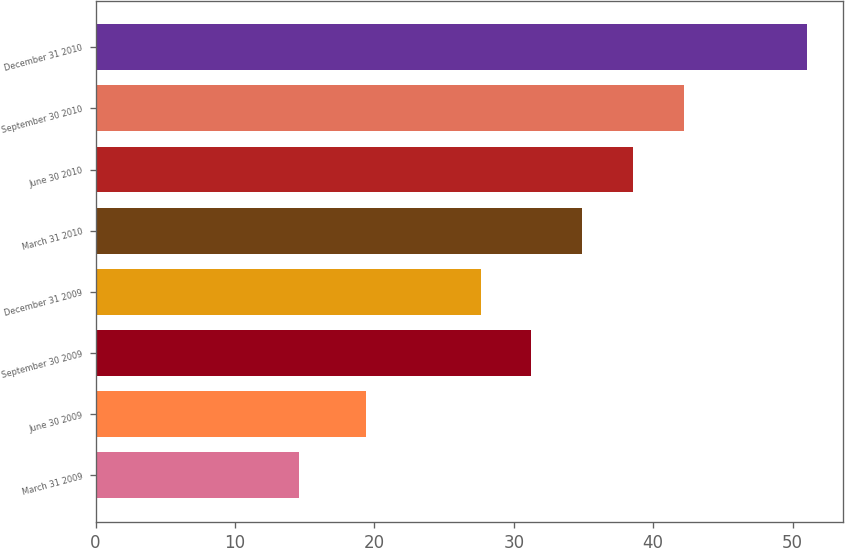Convert chart to OTSL. <chart><loc_0><loc_0><loc_500><loc_500><bar_chart><fcel>March 31 2009<fcel>June 30 2009<fcel>September 30 2009<fcel>December 31 2009<fcel>March 31 2010<fcel>June 30 2010<fcel>September 30 2010<fcel>December 31 2010<nl><fcel>14.62<fcel>19.4<fcel>31.26<fcel>27.62<fcel>34.9<fcel>38.54<fcel>42.18<fcel>51.06<nl></chart> 